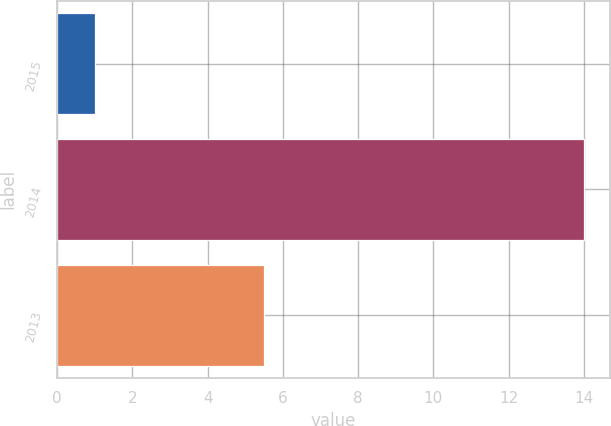<chart> <loc_0><loc_0><loc_500><loc_500><bar_chart><fcel>2015<fcel>2014<fcel>2013<nl><fcel>1<fcel>14<fcel>5.5<nl></chart> 